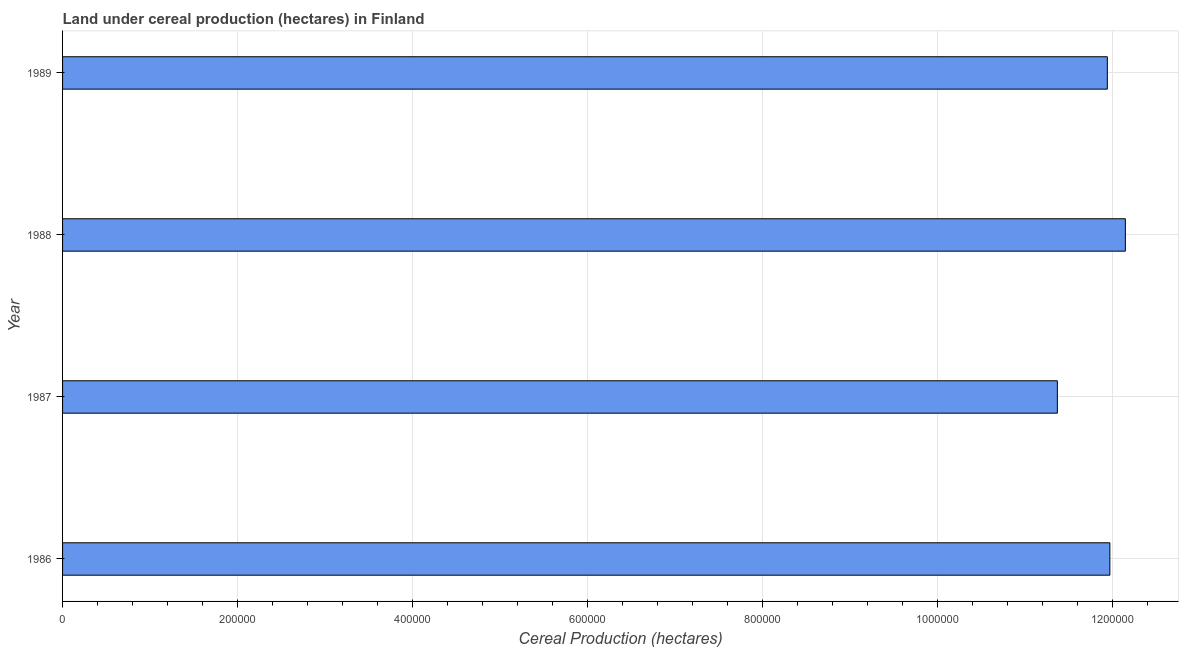What is the title of the graph?
Offer a terse response. Land under cereal production (hectares) in Finland. What is the label or title of the X-axis?
Provide a succinct answer. Cereal Production (hectares). What is the land under cereal production in 1989?
Keep it short and to the point. 1.19e+06. Across all years, what is the maximum land under cereal production?
Provide a succinct answer. 1.21e+06. Across all years, what is the minimum land under cereal production?
Your answer should be compact. 1.14e+06. In which year was the land under cereal production maximum?
Ensure brevity in your answer.  1988. What is the sum of the land under cereal production?
Give a very brief answer. 4.74e+06. What is the difference between the land under cereal production in 1987 and 1989?
Make the answer very short. -5.71e+04. What is the average land under cereal production per year?
Provide a succinct answer. 1.19e+06. What is the median land under cereal production?
Your response must be concise. 1.20e+06. Do a majority of the years between 1987 and 1988 (inclusive) have land under cereal production greater than 1160000 hectares?
Provide a short and direct response. No. Is the land under cereal production in 1988 less than that in 1989?
Offer a very short reply. No. What is the difference between the highest and the second highest land under cereal production?
Provide a short and direct response. 1.77e+04. Is the sum of the land under cereal production in 1987 and 1988 greater than the maximum land under cereal production across all years?
Provide a succinct answer. Yes. What is the difference between the highest and the lowest land under cereal production?
Provide a succinct answer. 7.77e+04. In how many years, is the land under cereal production greater than the average land under cereal production taken over all years?
Provide a short and direct response. 3. How many bars are there?
Offer a very short reply. 4. Are all the bars in the graph horizontal?
Make the answer very short. Yes. What is the Cereal Production (hectares) of 1986?
Provide a short and direct response. 1.20e+06. What is the Cereal Production (hectares) of 1987?
Offer a terse response. 1.14e+06. What is the Cereal Production (hectares) of 1988?
Your answer should be compact. 1.21e+06. What is the Cereal Production (hectares) of 1989?
Offer a terse response. 1.19e+06. What is the difference between the Cereal Production (hectares) in 1986 and 1987?
Keep it short and to the point. 6.00e+04. What is the difference between the Cereal Production (hectares) in 1986 and 1988?
Give a very brief answer. -1.77e+04. What is the difference between the Cereal Production (hectares) in 1986 and 1989?
Your answer should be very brief. 2900. What is the difference between the Cereal Production (hectares) in 1987 and 1988?
Your response must be concise. -7.77e+04. What is the difference between the Cereal Production (hectares) in 1987 and 1989?
Provide a short and direct response. -5.71e+04. What is the difference between the Cereal Production (hectares) in 1988 and 1989?
Give a very brief answer. 2.06e+04. What is the ratio of the Cereal Production (hectares) in 1986 to that in 1987?
Keep it short and to the point. 1.05. What is the ratio of the Cereal Production (hectares) in 1987 to that in 1988?
Ensure brevity in your answer.  0.94. 